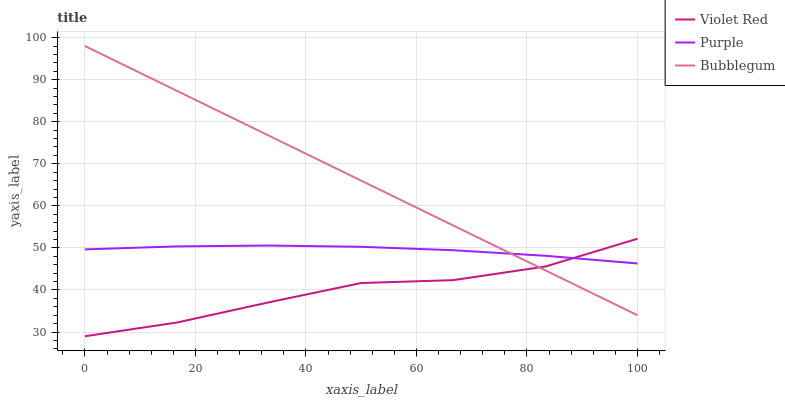Does Violet Red have the minimum area under the curve?
Answer yes or no. Yes. Does Bubblegum have the maximum area under the curve?
Answer yes or no. Yes. Does Bubblegum have the minimum area under the curve?
Answer yes or no. No. Does Violet Red have the maximum area under the curve?
Answer yes or no. No. Is Bubblegum the smoothest?
Answer yes or no. Yes. Is Violet Red the roughest?
Answer yes or no. Yes. Is Violet Red the smoothest?
Answer yes or no. No. Is Bubblegum the roughest?
Answer yes or no. No. Does Violet Red have the lowest value?
Answer yes or no. Yes. Does Bubblegum have the lowest value?
Answer yes or no. No. Does Bubblegum have the highest value?
Answer yes or no. Yes. Does Violet Red have the highest value?
Answer yes or no. No. Does Purple intersect Bubblegum?
Answer yes or no. Yes. Is Purple less than Bubblegum?
Answer yes or no. No. Is Purple greater than Bubblegum?
Answer yes or no. No. 